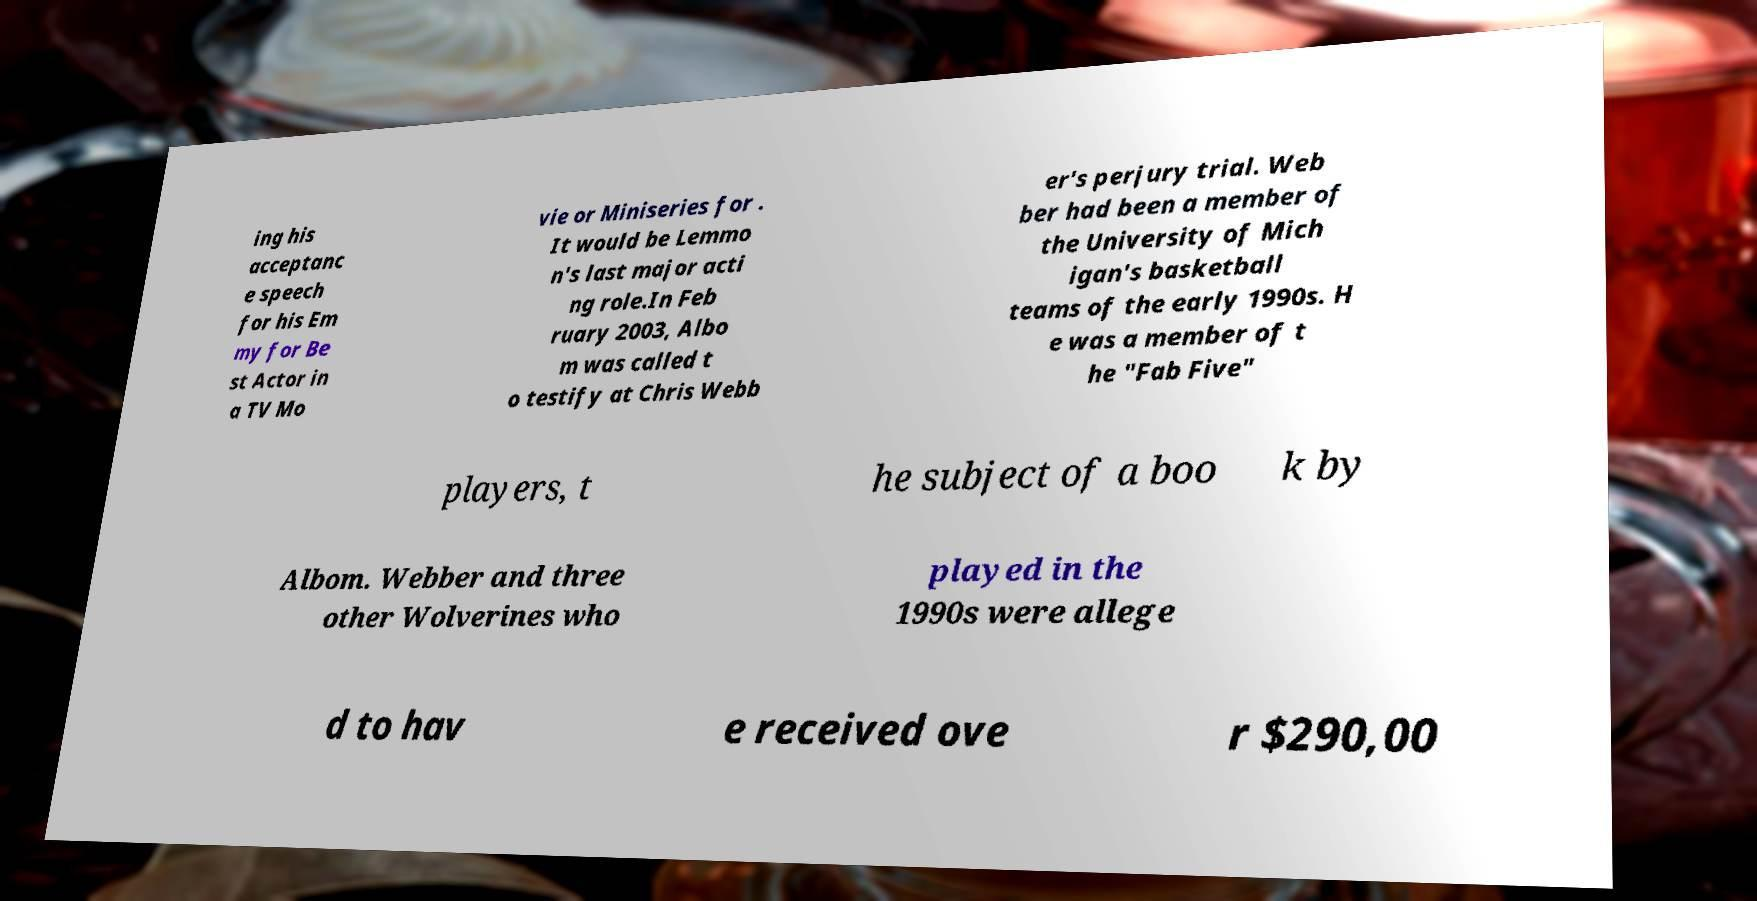For documentation purposes, I need the text within this image transcribed. Could you provide that? ing his acceptanc e speech for his Em my for Be st Actor in a TV Mo vie or Miniseries for . It would be Lemmo n's last major acti ng role.In Feb ruary 2003, Albo m was called t o testify at Chris Webb er's perjury trial. Web ber had been a member of the University of Mich igan's basketball teams of the early 1990s. H e was a member of t he "Fab Five" players, t he subject of a boo k by Albom. Webber and three other Wolverines who played in the 1990s were allege d to hav e received ove r $290,00 